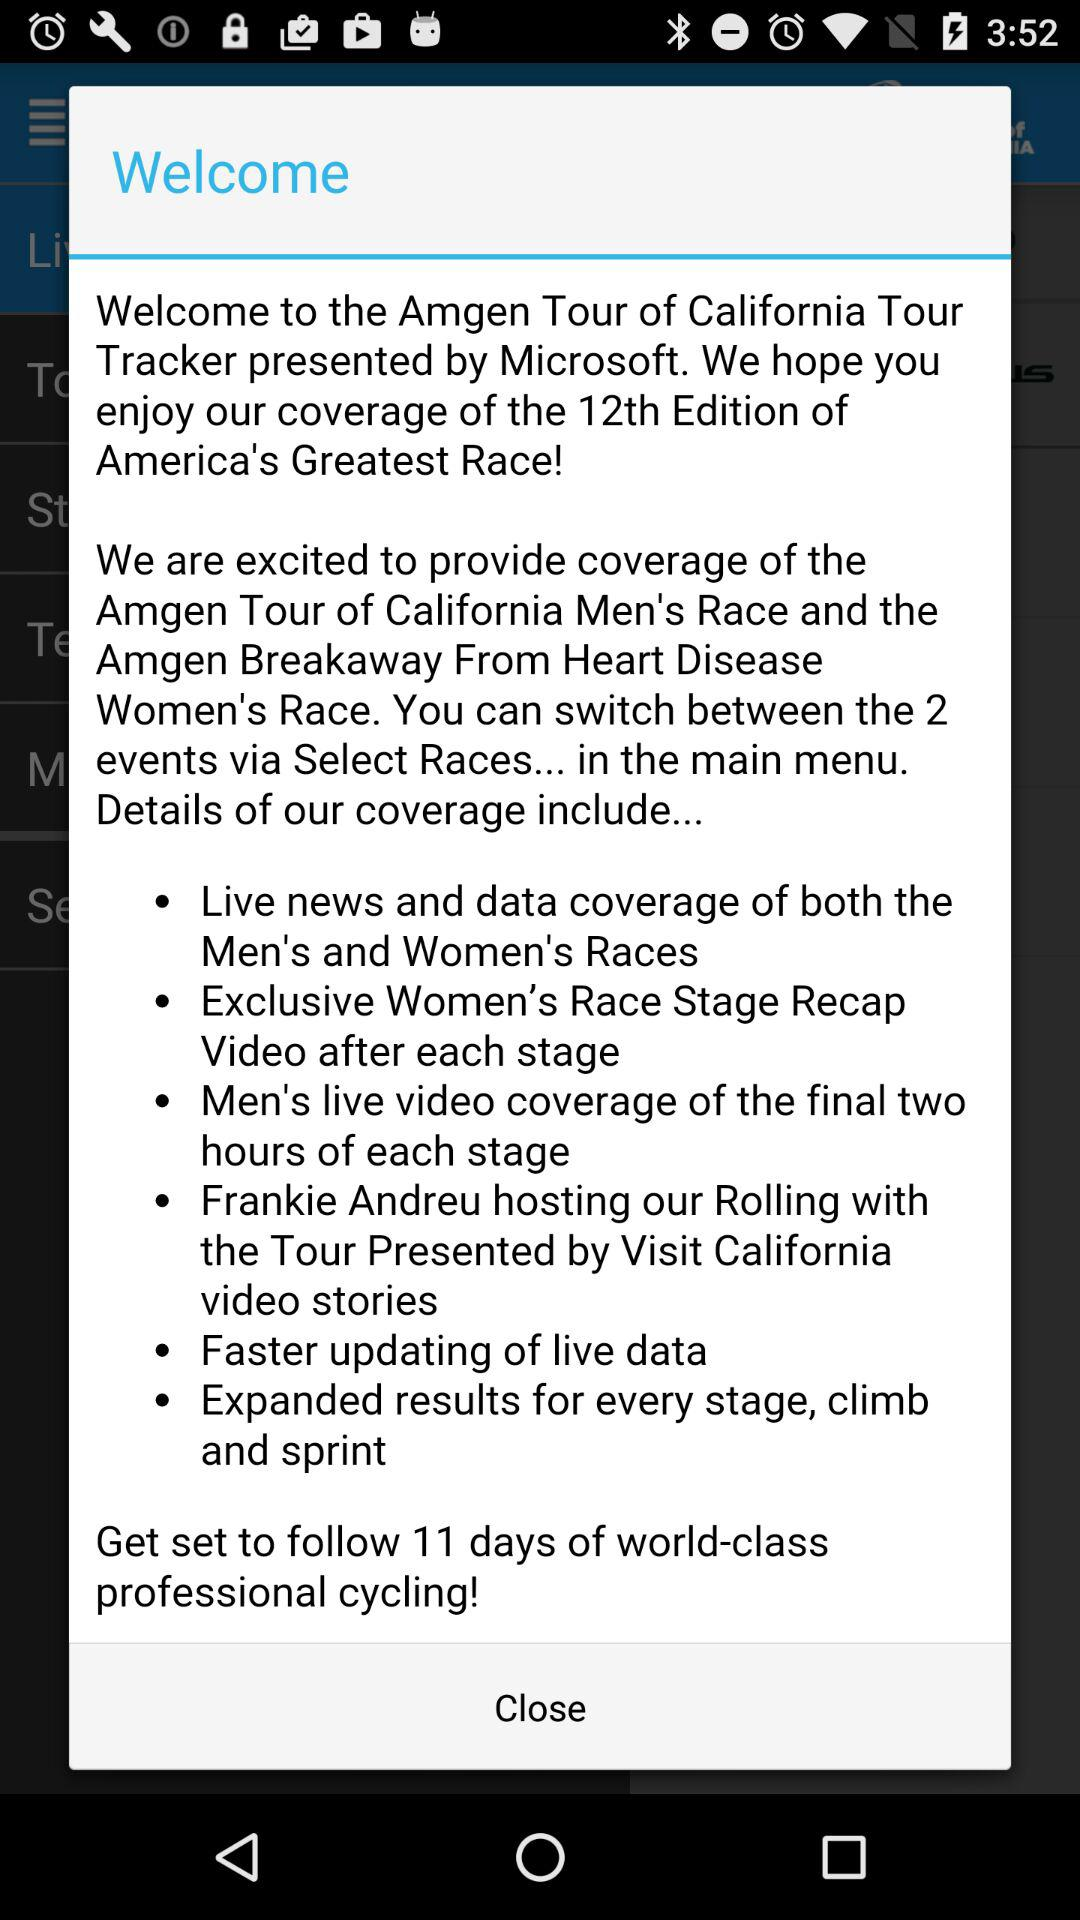Who is hosting this event?
When the provided information is insufficient, respond with <no answer>. <no answer> 